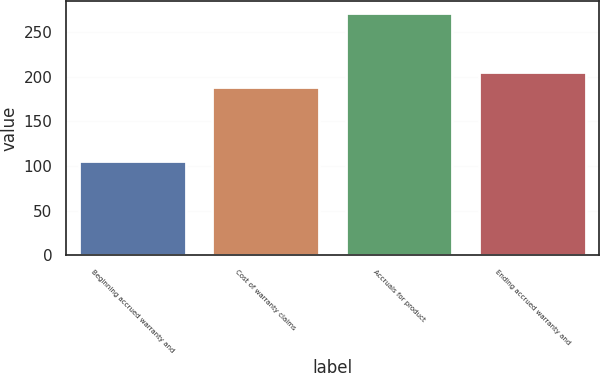<chart> <loc_0><loc_0><loc_500><loc_500><bar_chart><fcel>Beginning accrued warranty and<fcel>Cost of warranty claims<fcel>Accruals for product<fcel>Ending accrued warranty and<nl><fcel>105<fcel>188<fcel>271<fcel>204.6<nl></chart> 